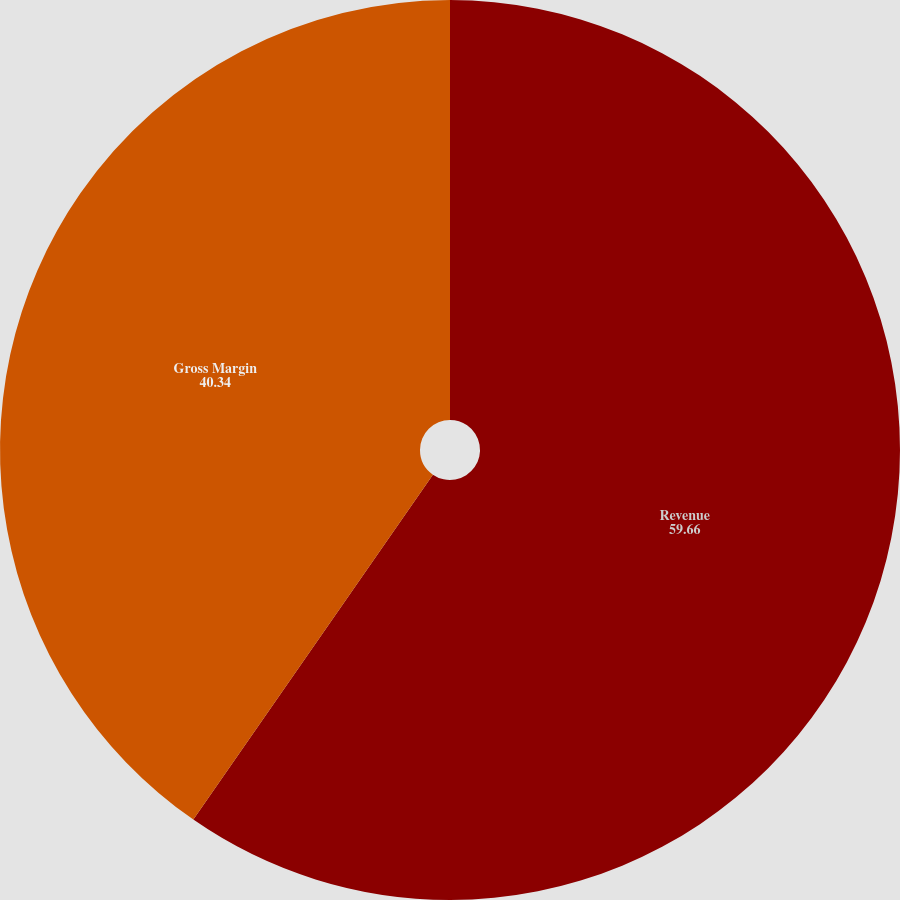<chart> <loc_0><loc_0><loc_500><loc_500><pie_chart><fcel>Revenue<fcel>Gross Margin<nl><fcel>59.66%<fcel>40.34%<nl></chart> 